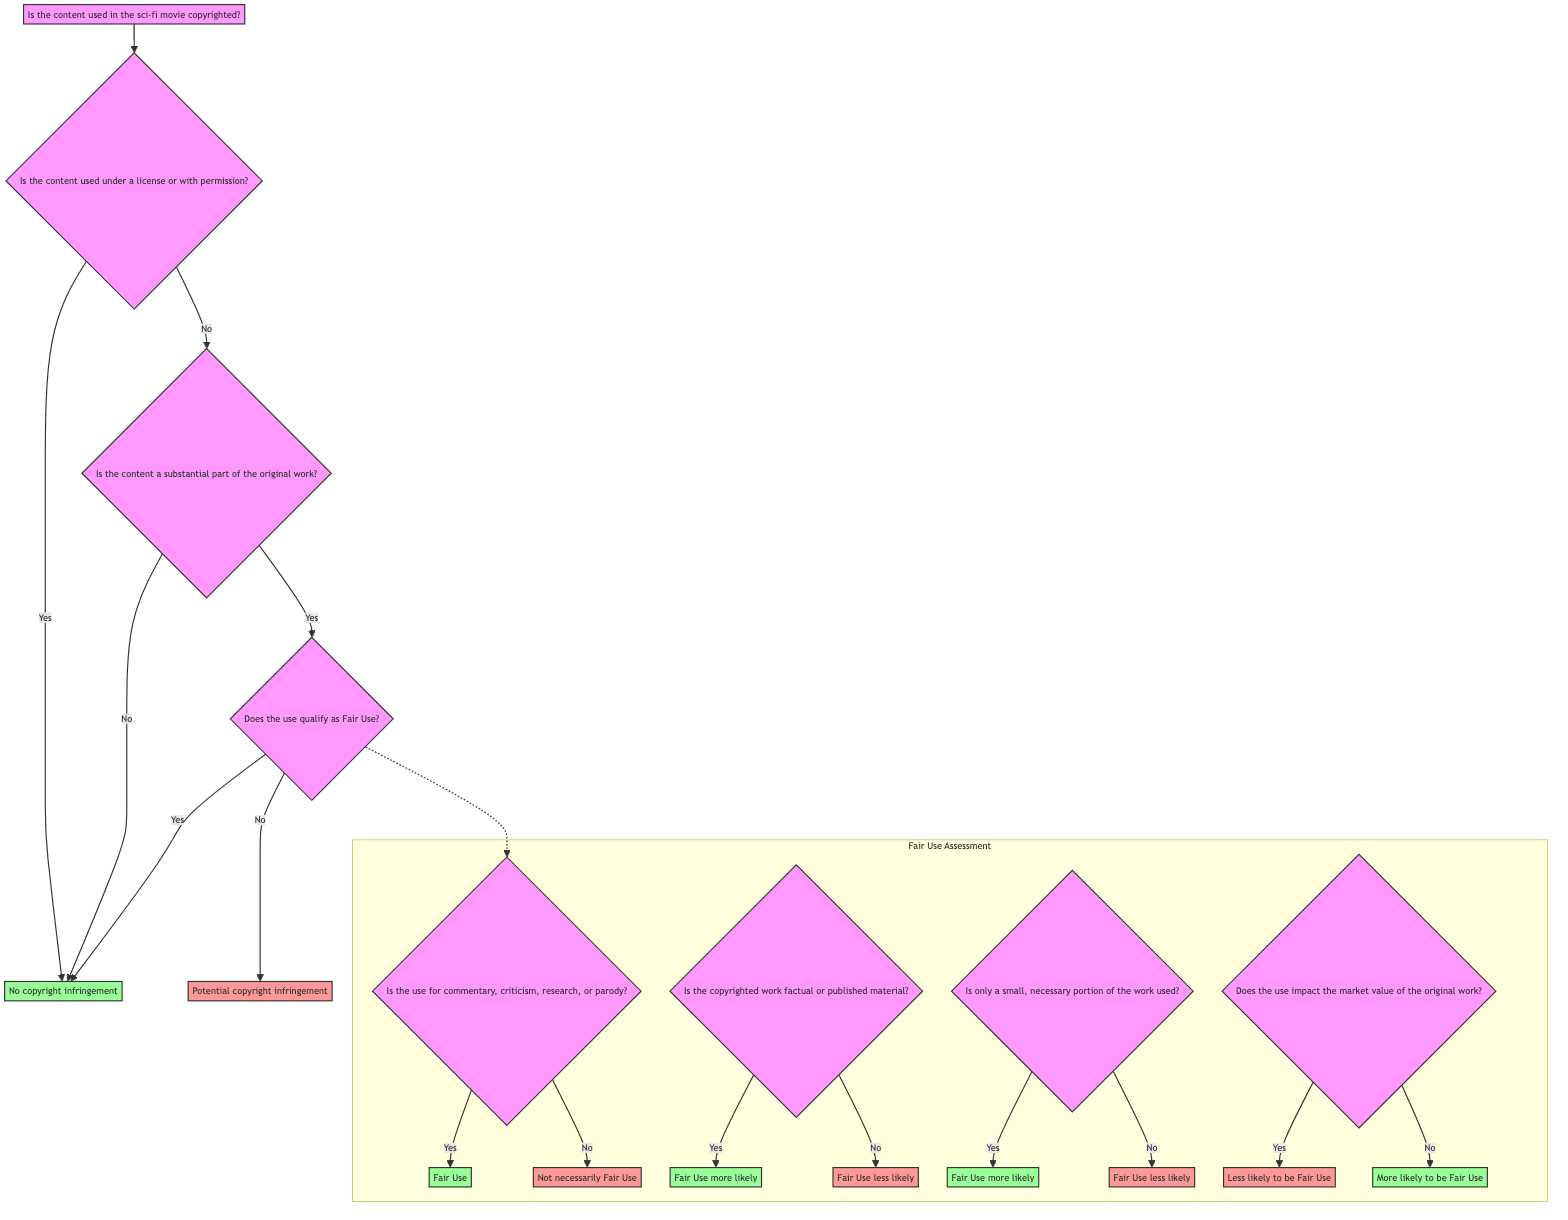What is the first question in the decision tree? The first question in the decision tree is about whether the content used in the sci-fi movie is copyrighted. This is identified as node A at the top of the diagram, which the flow begins from.
Answer: Is the content used in the sci-fi movie copyrighted? How many nodes are there in the decision tree? The decision tree contains a total of 7 nodes: 1 starting node (A), 4 decision nodes (B, C, D, G), and 2 end nodes (E, F). Counting them gives us a total of 7.
Answer: 7 What is the outcome if the content is copyrighted and used under a license? If the content is copyrighted and used under a license, the decision tree specifies a direct outcome of "No copyright infringement," which is the response from node B when the answer is yes.
Answer: No copyright infringement What happens if the content is a substantial part of the original work and does not qualify as Fair Use? If the content is a substantial part of the original work and does not qualify as Fair Use, the outcome is "Potential copyright infringement." This follows from nodes C and D leading to the response at node F.
Answer: Potential copyright infringement If the use of content is for commentary, which Fair Use criteria does it meet? If the use of the content is for commentary, it meets the Fair Use criteria, leading to the node response "Fair Use." This is determined at node G, where a positive answer confirms Fair Use.
Answer: Fair Use Does not using the content impact the market value of the original work favor Fair Use? If the use of the content does not impact the market value of the original work, it suggests the use is "More likely to be Fair Use," as indicated at node J for the negative response.
Answer: More likely to be Fair Use What is the relationship between the Fair Use criteria and the initial decision about copyright? The Fair Use criteria are assessed only after establishing whether the content is copyrighted and if it is a substantial part of the original work. If these conditions are met, the flow diverges to node D for Fair Use assessment.
Answer: Fair Use criteria follow copyright determination What is an indication that the use of content is less likely to be Fair Use? An indication that the use of content is less likely to be Fair Use occurs if the use impacts the market value of the original work. This is revealed at node J with a yes response leading to "Less likely to be Fair Use."
Answer: Less likely to be Fair Use 